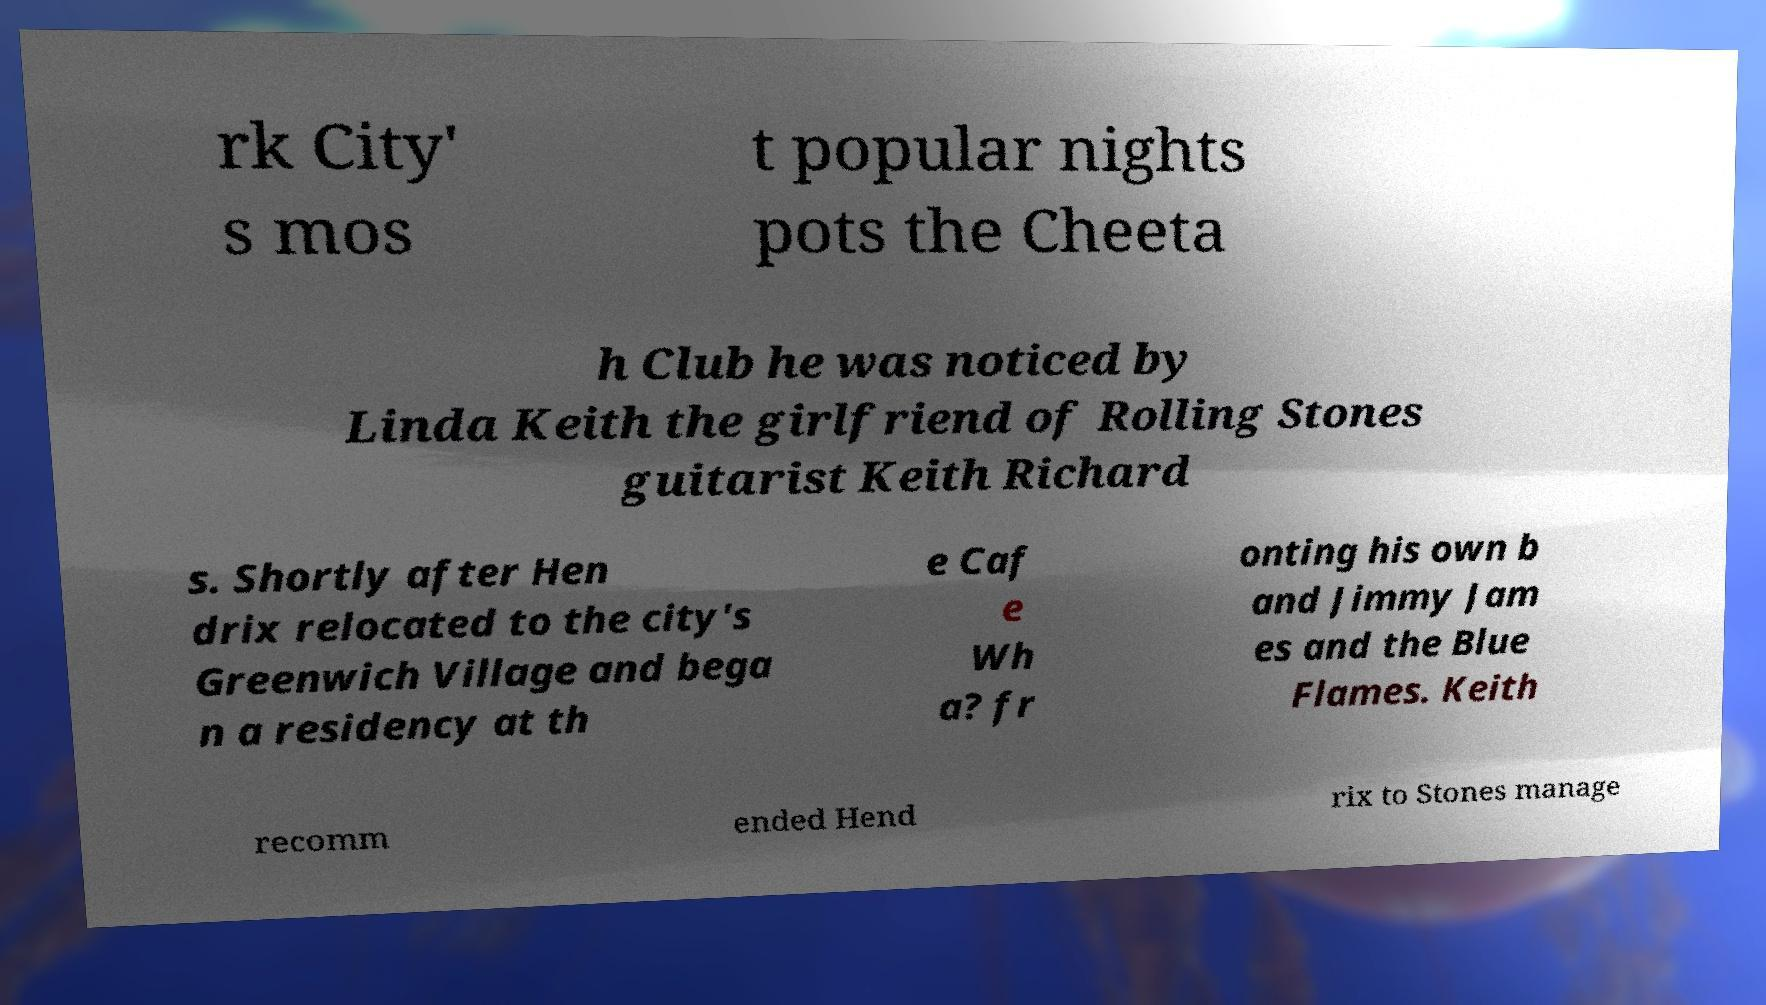Could you extract and type out the text from this image? rk City' s mos t popular nights pots the Cheeta h Club he was noticed by Linda Keith the girlfriend of Rolling Stones guitarist Keith Richard s. Shortly after Hen drix relocated to the city's Greenwich Village and bega n a residency at th e Caf e Wh a? fr onting his own b and Jimmy Jam es and the Blue Flames. Keith recomm ended Hend rix to Stones manage 